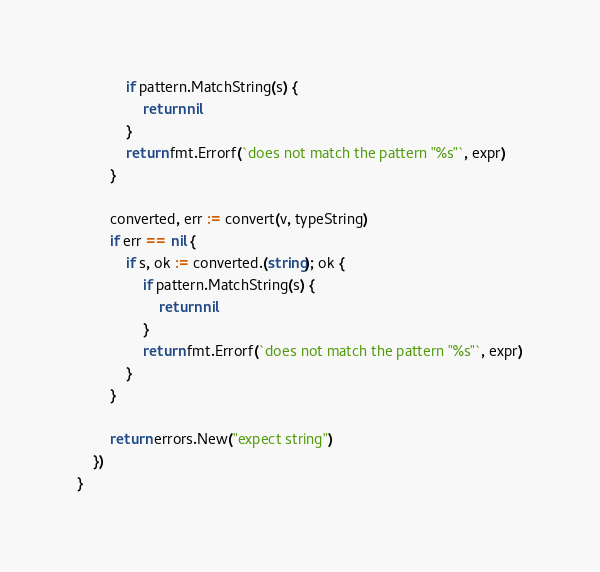Convert code to text. <code><loc_0><loc_0><loc_500><loc_500><_Go_>			if pattern.MatchString(s) {
				return nil
			}
			return fmt.Errorf(`does not match the pattern "%s"`, expr)
		}

		converted, err := convert(v, typeString)
		if err == nil {
			if s, ok := converted.(string); ok {
				if pattern.MatchString(s) {
					return nil
				}
				return fmt.Errorf(`does not match the pattern "%s"`, expr)
			}
		}

		return errors.New("expect string")
	})
}
</code> 